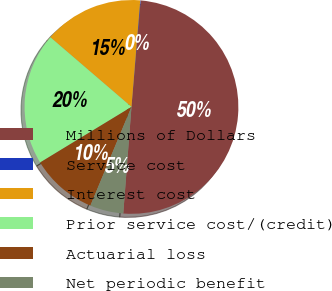Convert chart to OTSL. <chart><loc_0><loc_0><loc_500><loc_500><pie_chart><fcel>Millions of Dollars<fcel>Service cost<fcel>Interest cost<fcel>Prior service cost/(credit)<fcel>Actuarial loss<fcel>Net periodic benefit<nl><fcel>49.85%<fcel>0.07%<fcel>15.01%<fcel>19.99%<fcel>10.03%<fcel>5.05%<nl></chart> 